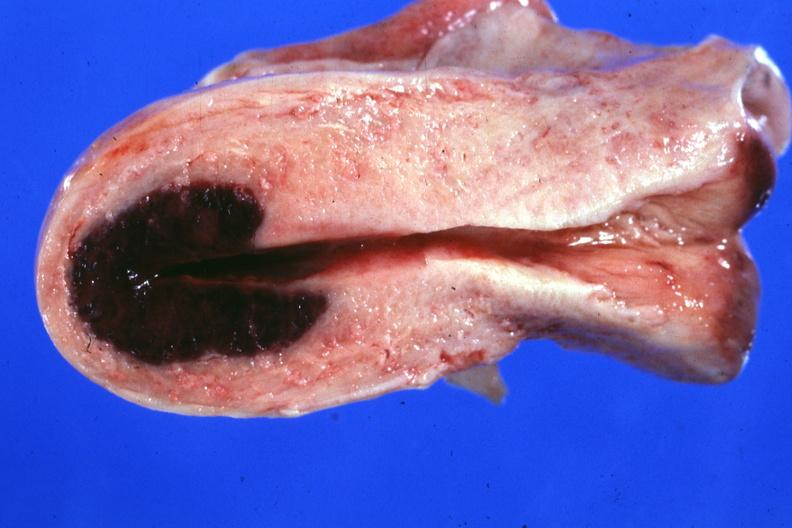what said to have adenosis adenomyosis hemorrhage probably due to shock?
Answer the question using a single word or phrase. Localized lesion in dome of uterus 